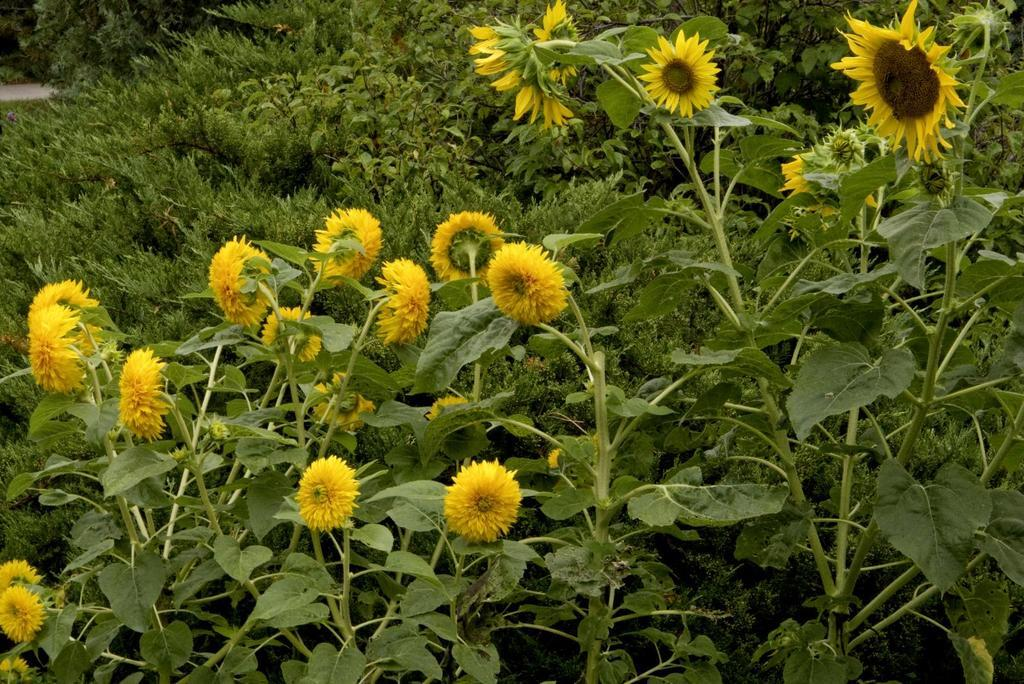What type of living organisms can be seen in the image? Plants can be seen in the image. Are there any specific features of the plants that can be observed? Yes, there are yellow flowers in the image. What type of print can be seen on the yellow flowers in the image? There is no print visible on the yellow flowers in the image. Can you see any evidence of the flowers being bitten or damaged in the image? There is no indication of the flowers being bitten or damaged in the image. 